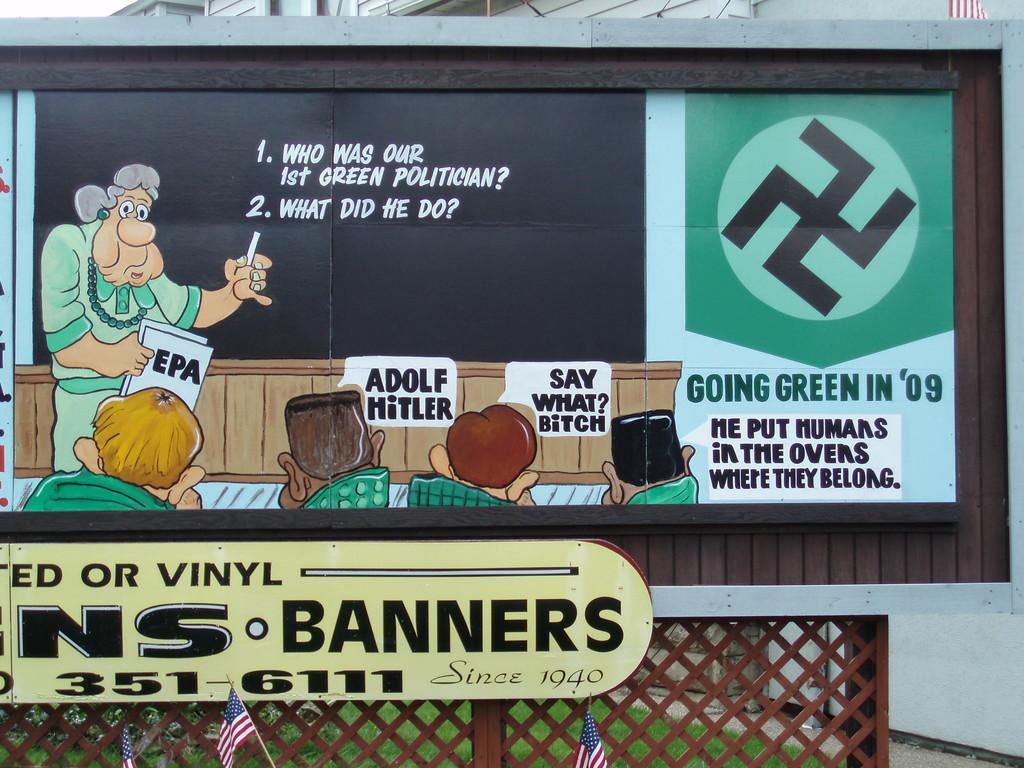Describe this image in one or two sentences. In this picture there is a poster in the center of the image and there are flags, greenery, and net boundary at the bottom side of the image, there is a building at the top side of the image. 